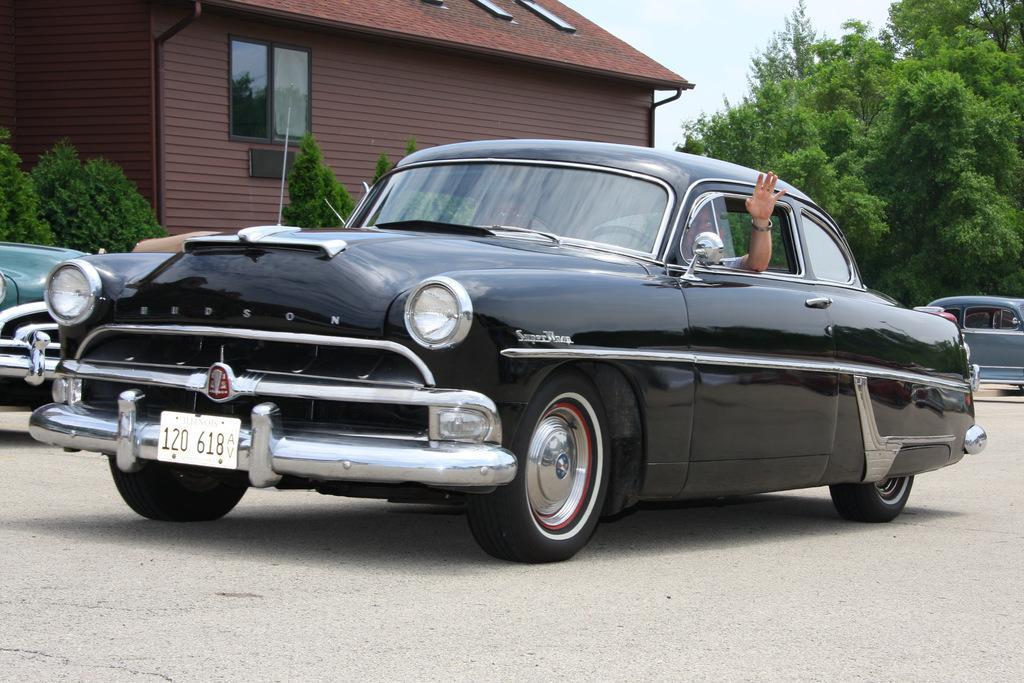In one or two sentences, can you explain what this image depicts? In the foreground of this image, there is a black car on the road and a hand outside through the window of the car. In the background, there is a house, few trees, two cars and the sky. 